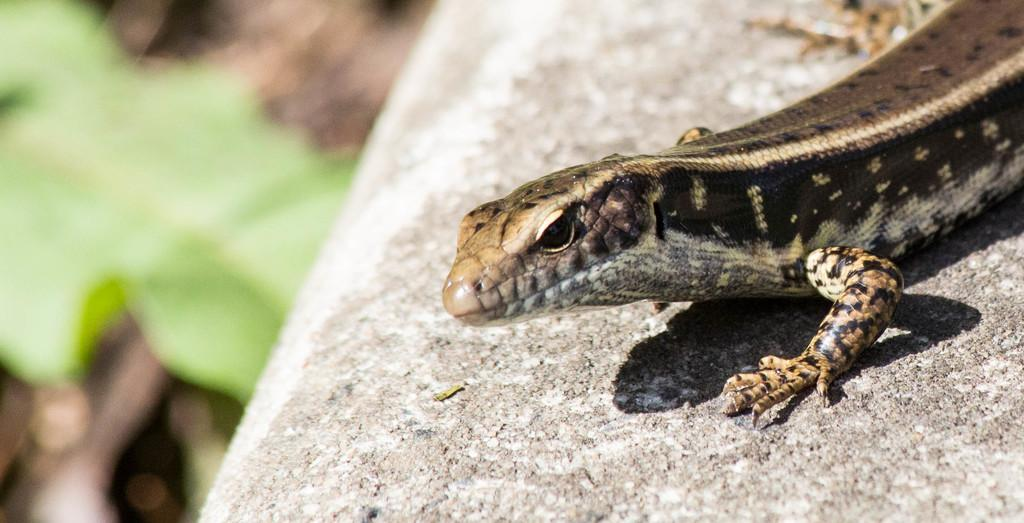What type of animal is present on the surface in the image? There is a reptile on the surface in the image. Can you describe the background of the image? The background of the image is blurry. What type of stick can be seen in the image? There is no stick present in the image. What discovery was made by the reptile in the image? The image does not depict any discovery made by the reptile. 